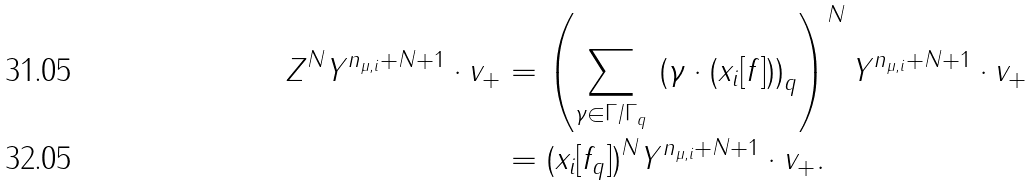<formula> <loc_0><loc_0><loc_500><loc_500>Z ^ { N } Y ^ { n _ { \mu , i } + N + 1 } \cdot v _ { + } & = \left ( \sum _ { \gamma \in \Gamma / \Gamma _ { q } } \, \left ( \gamma \cdot ( x _ { i } [ f ] ) \right ) _ { q } \right ) ^ { N } Y ^ { n _ { \mu , i } + N + 1 } \cdot v _ { + } \\ & = ( x _ { i } [ f _ { q } ] ) ^ { N } Y ^ { n _ { \mu , i } + N + 1 } \cdot v _ { + } .</formula> 